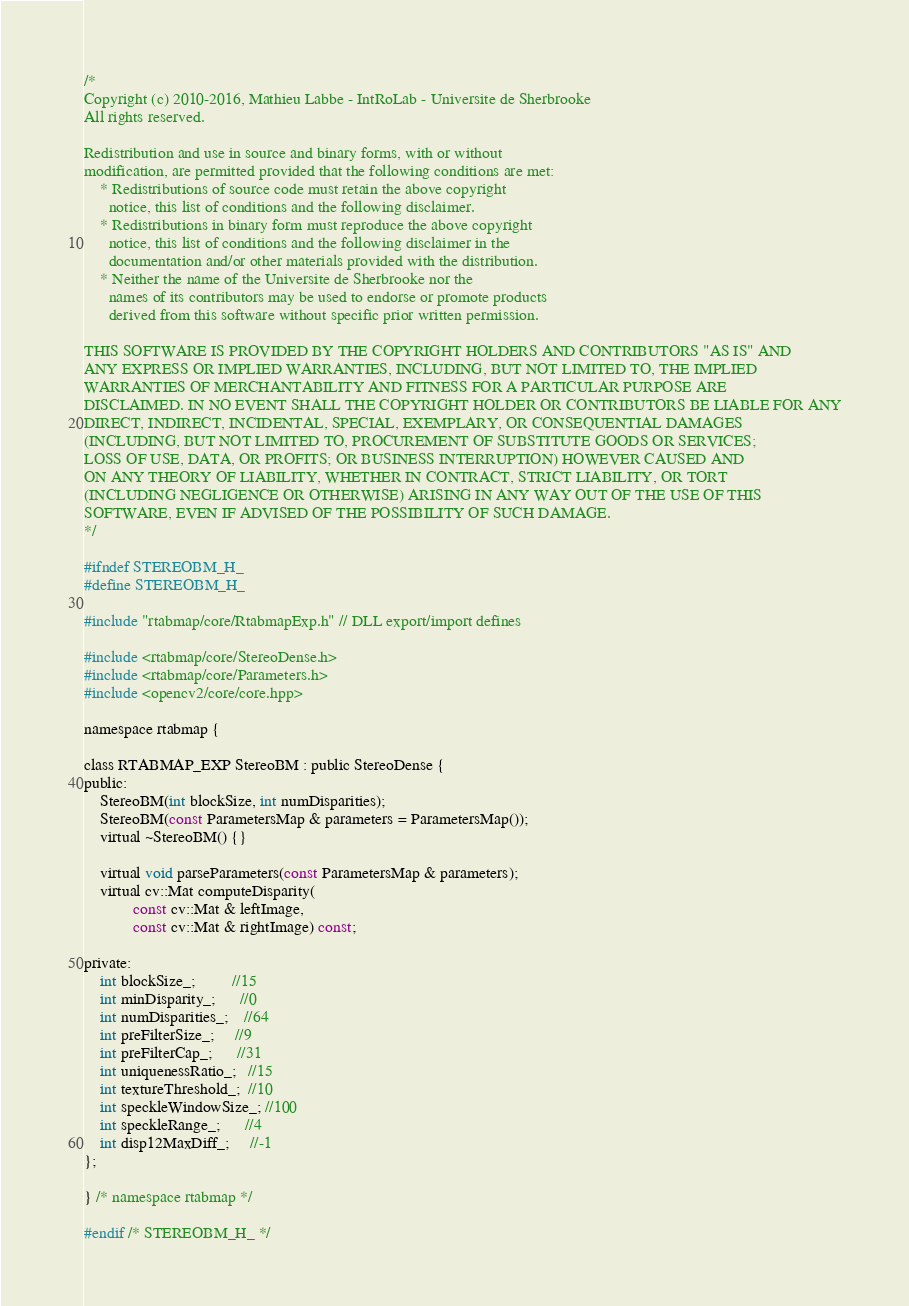<code> <loc_0><loc_0><loc_500><loc_500><_C_>/*
Copyright (c) 2010-2016, Mathieu Labbe - IntRoLab - Universite de Sherbrooke
All rights reserved.

Redistribution and use in source and binary forms, with or without
modification, are permitted provided that the following conditions are met:
    * Redistributions of source code must retain the above copyright
      notice, this list of conditions and the following disclaimer.
    * Redistributions in binary form must reproduce the above copyright
      notice, this list of conditions and the following disclaimer in the
      documentation and/or other materials provided with the distribution.
    * Neither the name of the Universite de Sherbrooke nor the
      names of its contributors may be used to endorse or promote products
      derived from this software without specific prior written permission.

THIS SOFTWARE IS PROVIDED BY THE COPYRIGHT HOLDERS AND CONTRIBUTORS "AS IS" AND
ANY EXPRESS OR IMPLIED WARRANTIES, INCLUDING, BUT NOT LIMITED TO, THE IMPLIED
WARRANTIES OF MERCHANTABILITY AND FITNESS FOR A PARTICULAR PURPOSE ARE
DISCLAIMED. IN NO EVENT SHALL THE COPYRIGHT HOLDER OR CONTRIBUTORS BE LIABLE FOR ANY
DIRECT, INDIRECT, INCIDENTAL, SPECIAL, EXEMPLARY, OR CONSEQUENTIAL DAMAGES
(INCLUDING, BUT NOT LIMITED TO, PROCUREMENT OF SUBSTITUTE GOODS OR SERVICES;
LOSS OF USE, DATA, OR PROFITS; OR BUSINESS INTERRUPTION) HOWEVER CAUSED AND
ON ANY THEORY OF LIABILITY, WHETHER IN CONTRACT, STRICT LIABILITY, OR TORT
(INCLUDING NEGLIGENCE OR OTHERWISE) ARISING IN ANY WAY OUT OF THE USE OF THIS
SOFTWARE, EVEN IF ADVISED OF THE POSSIBILITY OF SUCH DAMAGE.
*/

#ifndef STEREOBM_H_
#define STEREOBM_H_

#include "rtabmap/core/RtabmapExp.h" // DLL export/import defines

#include <rtabmap/core/StereoDense.h>
#include <rtabmap/core/Parameters.h>
#include <opencv2/core/core.hpp>

namespace rtabmap {

class RTABMAP_EXP StereoBM : public StereoDense {
public:
	StereoBM(int blockSize, int numDisparities);
	StereoBM(const ParametersMap & parameters = ParametersMap());
	virtual ~StereoBM() {}

	virtual void parseParameters(const ParametersMap & parameters);
	virtual cv::Mat computeDisparity(
			const cv::Mat & leftImage,
			const cv::Mat & rightImage) const;

private:
	int blockSize_;         //15
	int minDisparity_;      //0
	int numDisparities_;    //64
	int preFilterSize_;     //9
	int preFilterCap_;      //31
	int uniquenessRatio_;   //15
	int textureThreshold_;  //10
	int speckleWindowSize_; //100
	int speckleRange_;      //4
	int disp12MaxDiff_;     //-1
};

} /* namespace rtabmap */

#endif /* STEREOBM_H_ */
</code> 